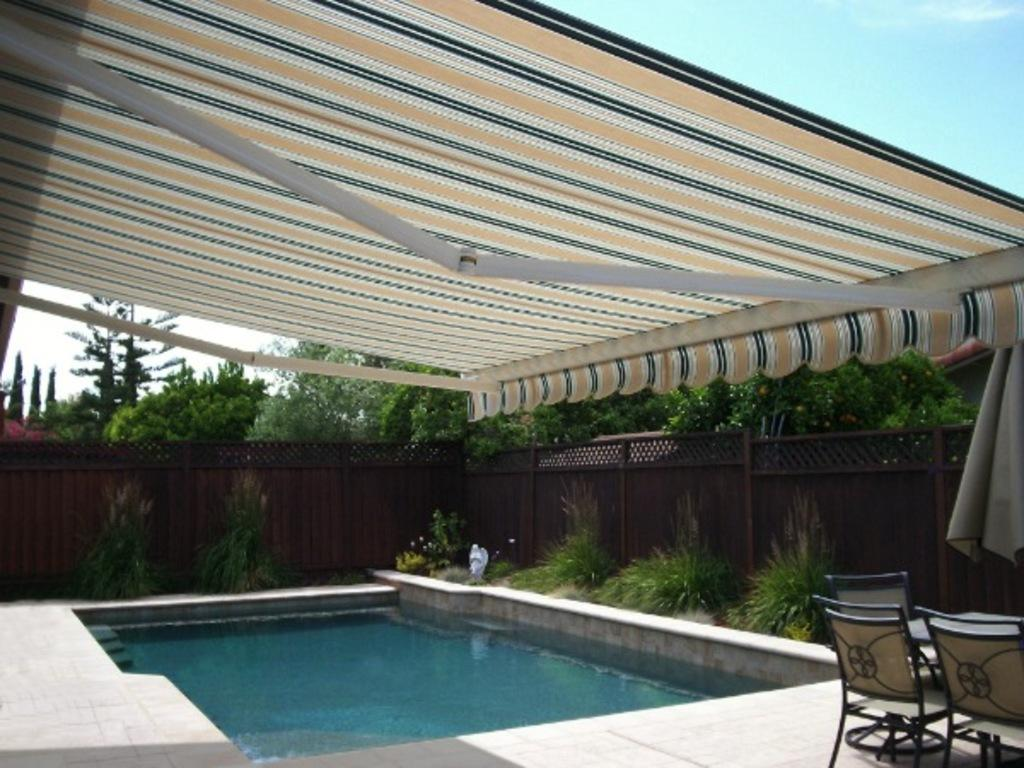What type of recreational area is depicted in the image? There is a swimming pool in the image, which suggests a recreational area. What type of temporary shelter is present in the image? There is a tent in the image. What type of vegetation is present in the image? There are trees in the image. What type of barrier is present in the image? There is a wooden fence in the image. What is visible in the sky in the image? There are clouds visible in the sky. What type of seating is present in the image? There are sitting chairs in the image. What type of pencil can be seen in the image? There is no pencil present in the image. What is the distance between the swimming pool and the tent in the image? The distance between the swimming pool and the tent cannot be determined from the image alone, as there is no scale provided. 